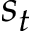<formula> <loc_0><loc_0><loc_500><loc_500>s _ { t }</formula> 